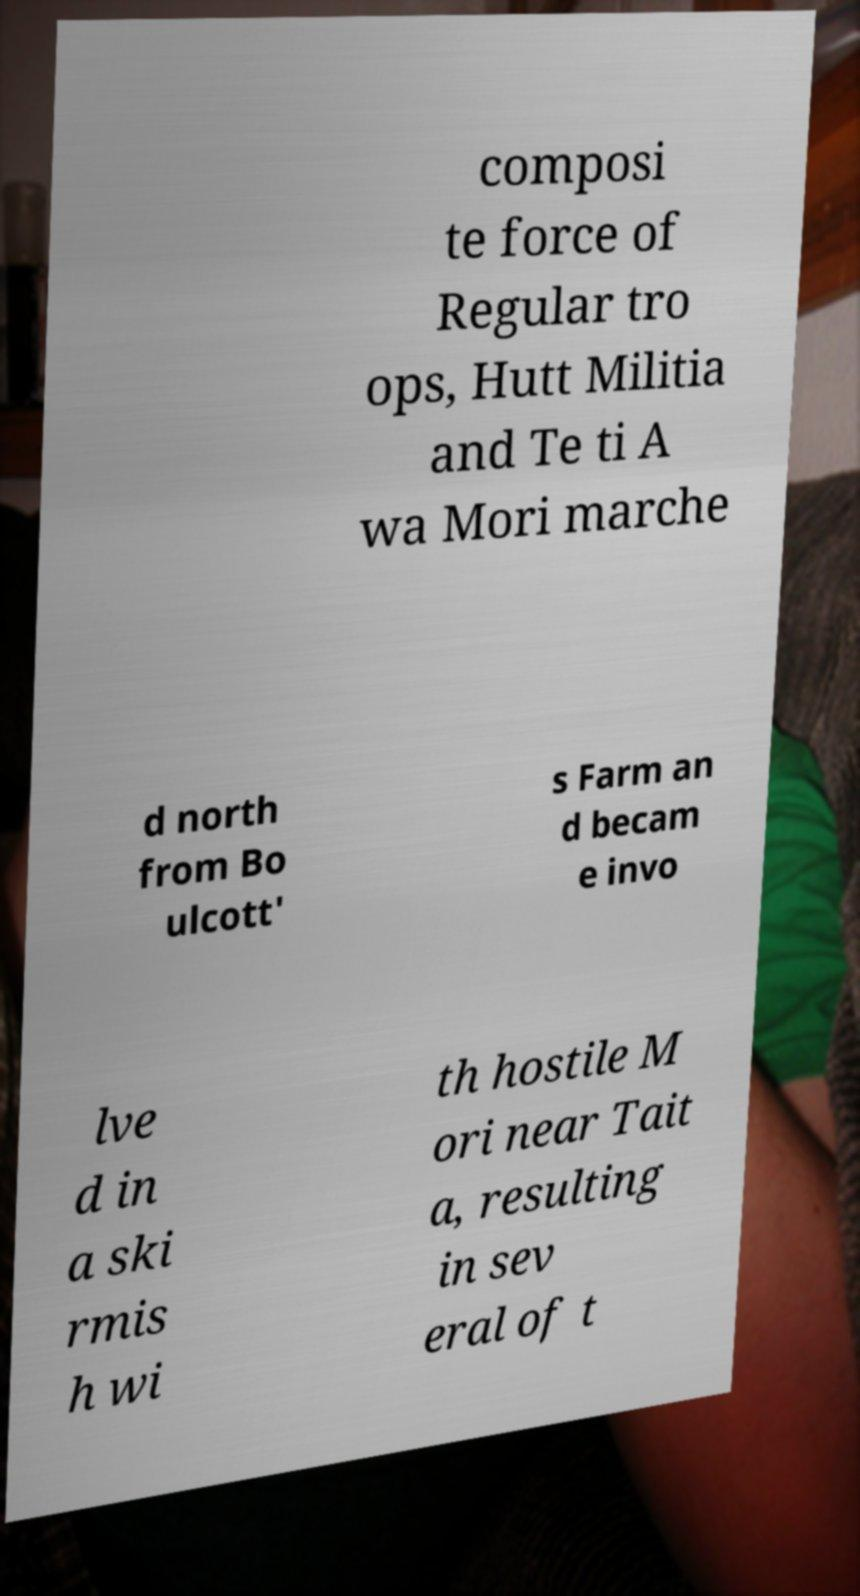There's text embedded in this image that I need extracted. Can you transcribe it verbatim? composi te force of Regular tro ops, Hutt Militia and Te ti A wa Mori marche d north from Bo ulcott' s Farm an d becam e invo lve d in a ski rmis h wi th hostile M ori near Tait a, resulting in sev eral of t 